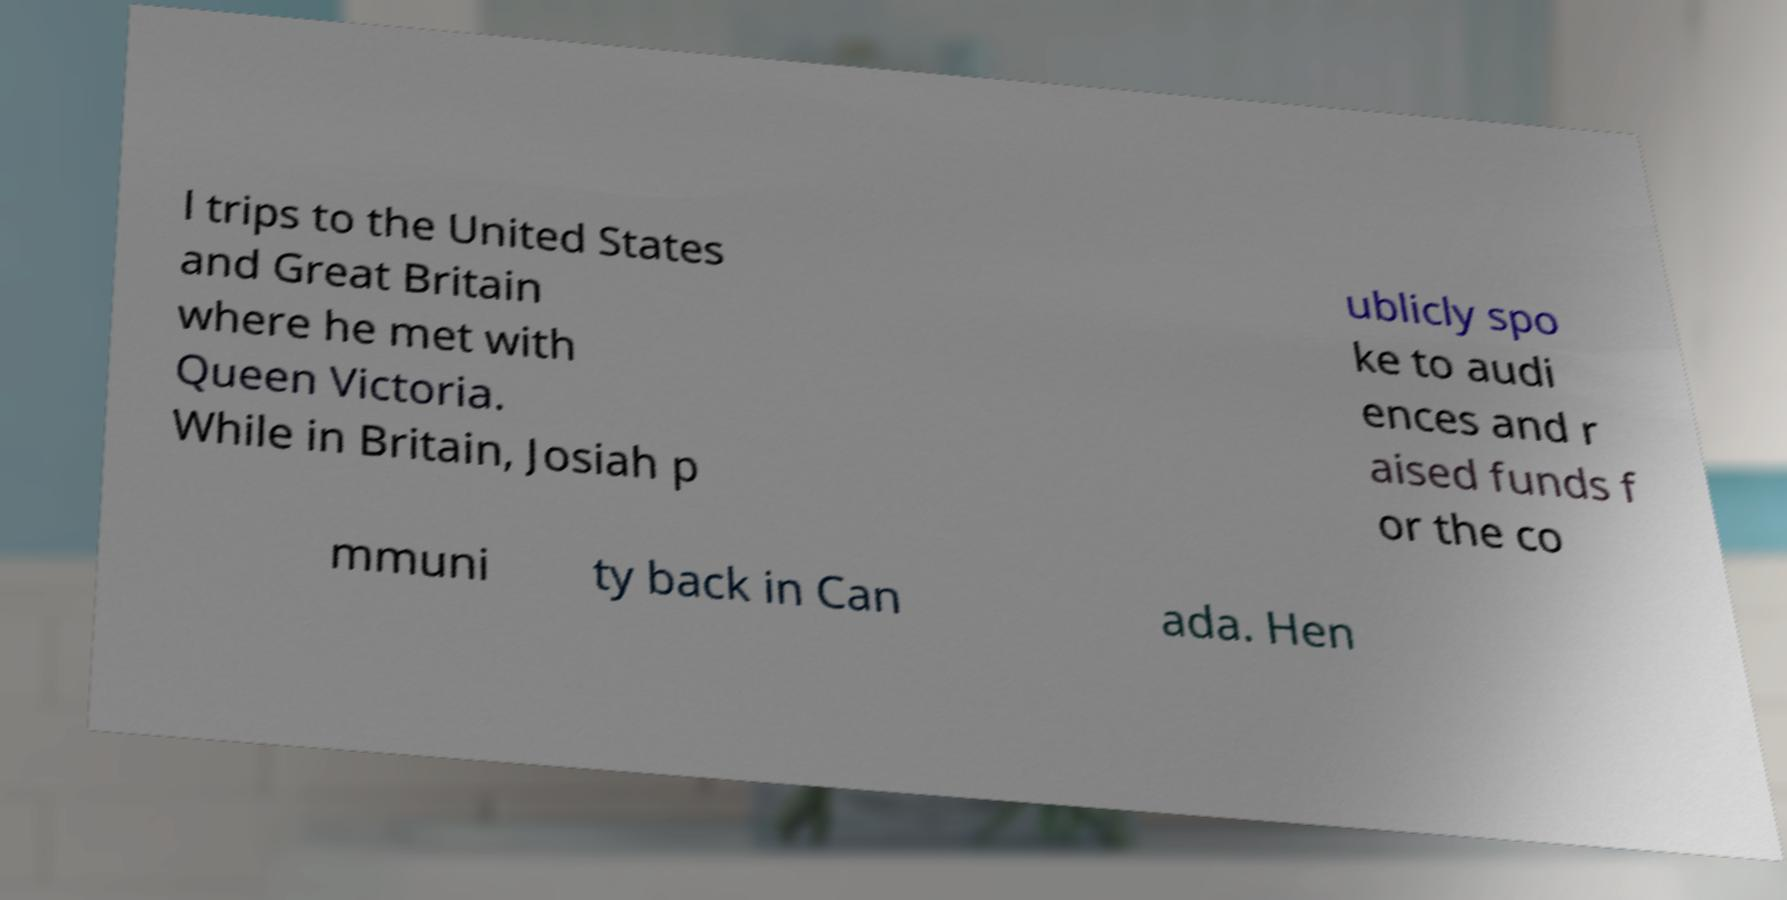What messages or text are displayed in this image? I need them in a readable, typed format. l trips to the United States and Great Britain where he met with Queen Victoria. While in Britain, Josiah p ublicly spo ke to audi ences and r aised funds f or the co mmuni ty back in Can ada. Hen 